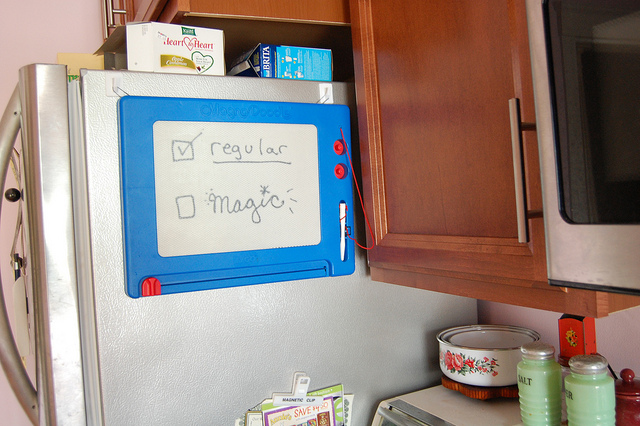Please transcribe the text information in this image. regular magic kart Heart BRITA 